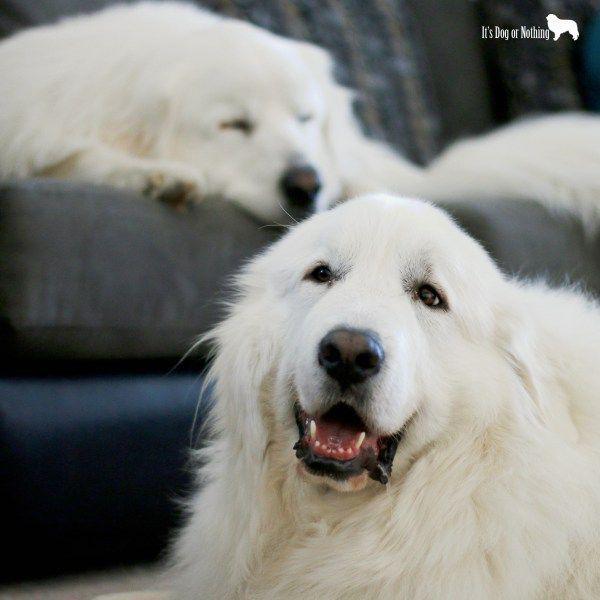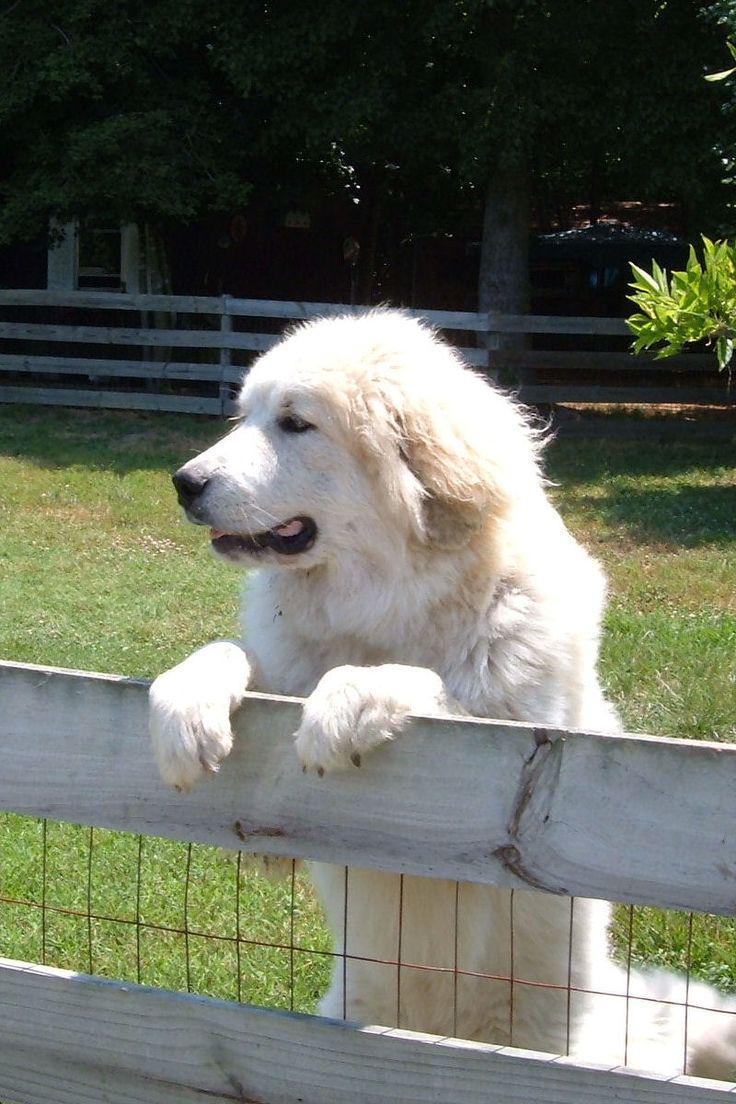The first image is the image on the left, the second image is the image on the right. Evaluate the accuracy of this statement regarding the images: "The dog int he image on the right is standing in a grassy area.". Is it true? Answer yes or no. Yes. The first image is the image on the left, the second image is the image on the right. Evaluate the accuracy of this statement regarding the images: "A white animal is sleeping by water in one of its states of matter.". Is it true? Answer yes or no. No. 